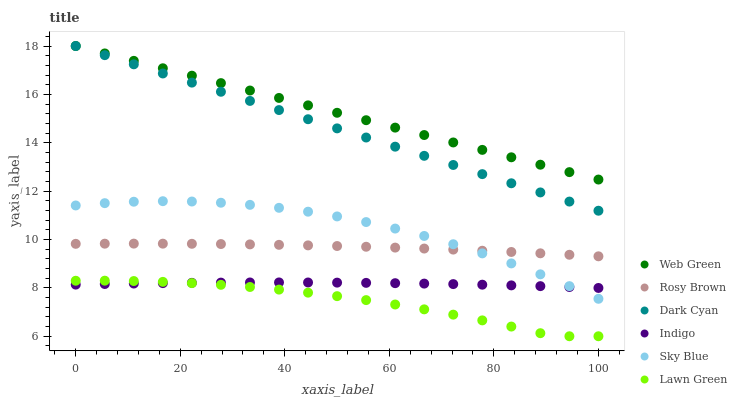Does Lawn Green have the minimum area under the curve?
Answer yes or no. Yes. Does Web Green have the maximum area under the curve?
Answer yes or no. Yes. Does Indigo have the minimum area under the curve?
Answer yes or no. No. Does Indigo have the maximum area under the curve?
Answer yes or no. No. Is Web Green the smoothest?
Answer yes or no. Yes. Is Sky Blue the roughest?
Answer yes or no. Yes. Is Indigo the smoothest?
Answer yes or no. No. Is Indigo the roughest?
Answer yes or no. No. Does Lawn Green have the lowest value?
Answer yes or no. Yes. Does Indigo have the lowest value?
Answer yes or no. No. Does Dark Cyan have the highest value?
Answer yes or no. Yes. Does Rosy Brown have the highest value?
Answer yes or no. No. Is Lawn Green less than Dark Cyan?
Answer yes or no. Yes. Is Dark Cyan greater than Sky Blue?
Answer yes or no. Yes. Does Rosy Brown intersect Sky Blue?
Answer yes or no. Yes. Is Rosy Brown less than Sky Blue?
Answer yes or no. No. Is Rosy Brown greater than Sky Blue?
Answer yes or no. No. Does Lawn Green intersect Dark Cyan?
Answer yes or no. No. 